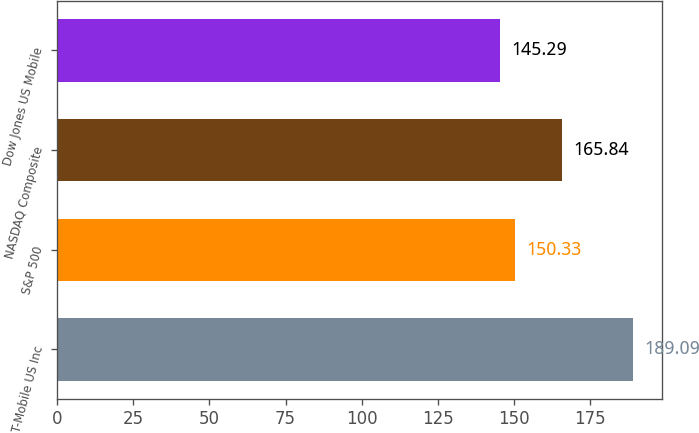Convert chart. <chart><loc_0><loc_0><loc_500><loc_500><bar_chart><fcel>T-Mobile US Inc<fcel>S&P 500<fcel>NASDAQ Composite<fcel>Dow Jones US Mobile<nl><fcel>189.09<fcel>150.33<fcel>165.84<fcel>145.29<nl></chart> 